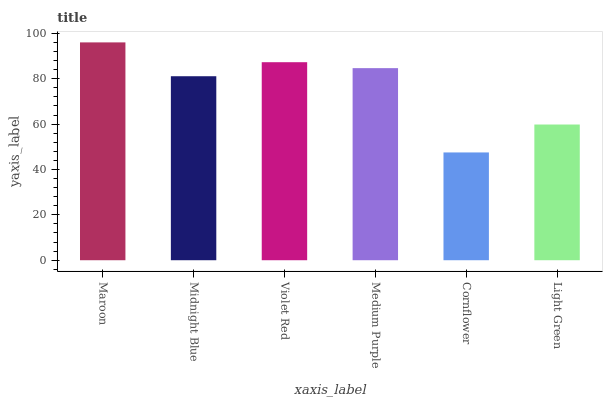Is Midnight Blue the minimum?
Answer yes or no. No. Is Midnight Blue the maximum?
Answer yes or no. No. Is Maroon greater than Midnight Blue?
Answer yes or no. Yes. Is Midnight Blue less than Maroon?
Answer yes or no. Yes. Is Midnight Blue greater than Maroon?
Answer yes or no. No. Is Maroon less than Midnight Blue?
Answer yes or no. No. Is Medium Purple the high median?
Answer yes or no. Yes. Is Midnight Blue the low median?
Answer yes or no. Yes. Is Violet Red the high median?
Answer yes or no. No. Is Light Green the low median?
Answer yes or no. No. 